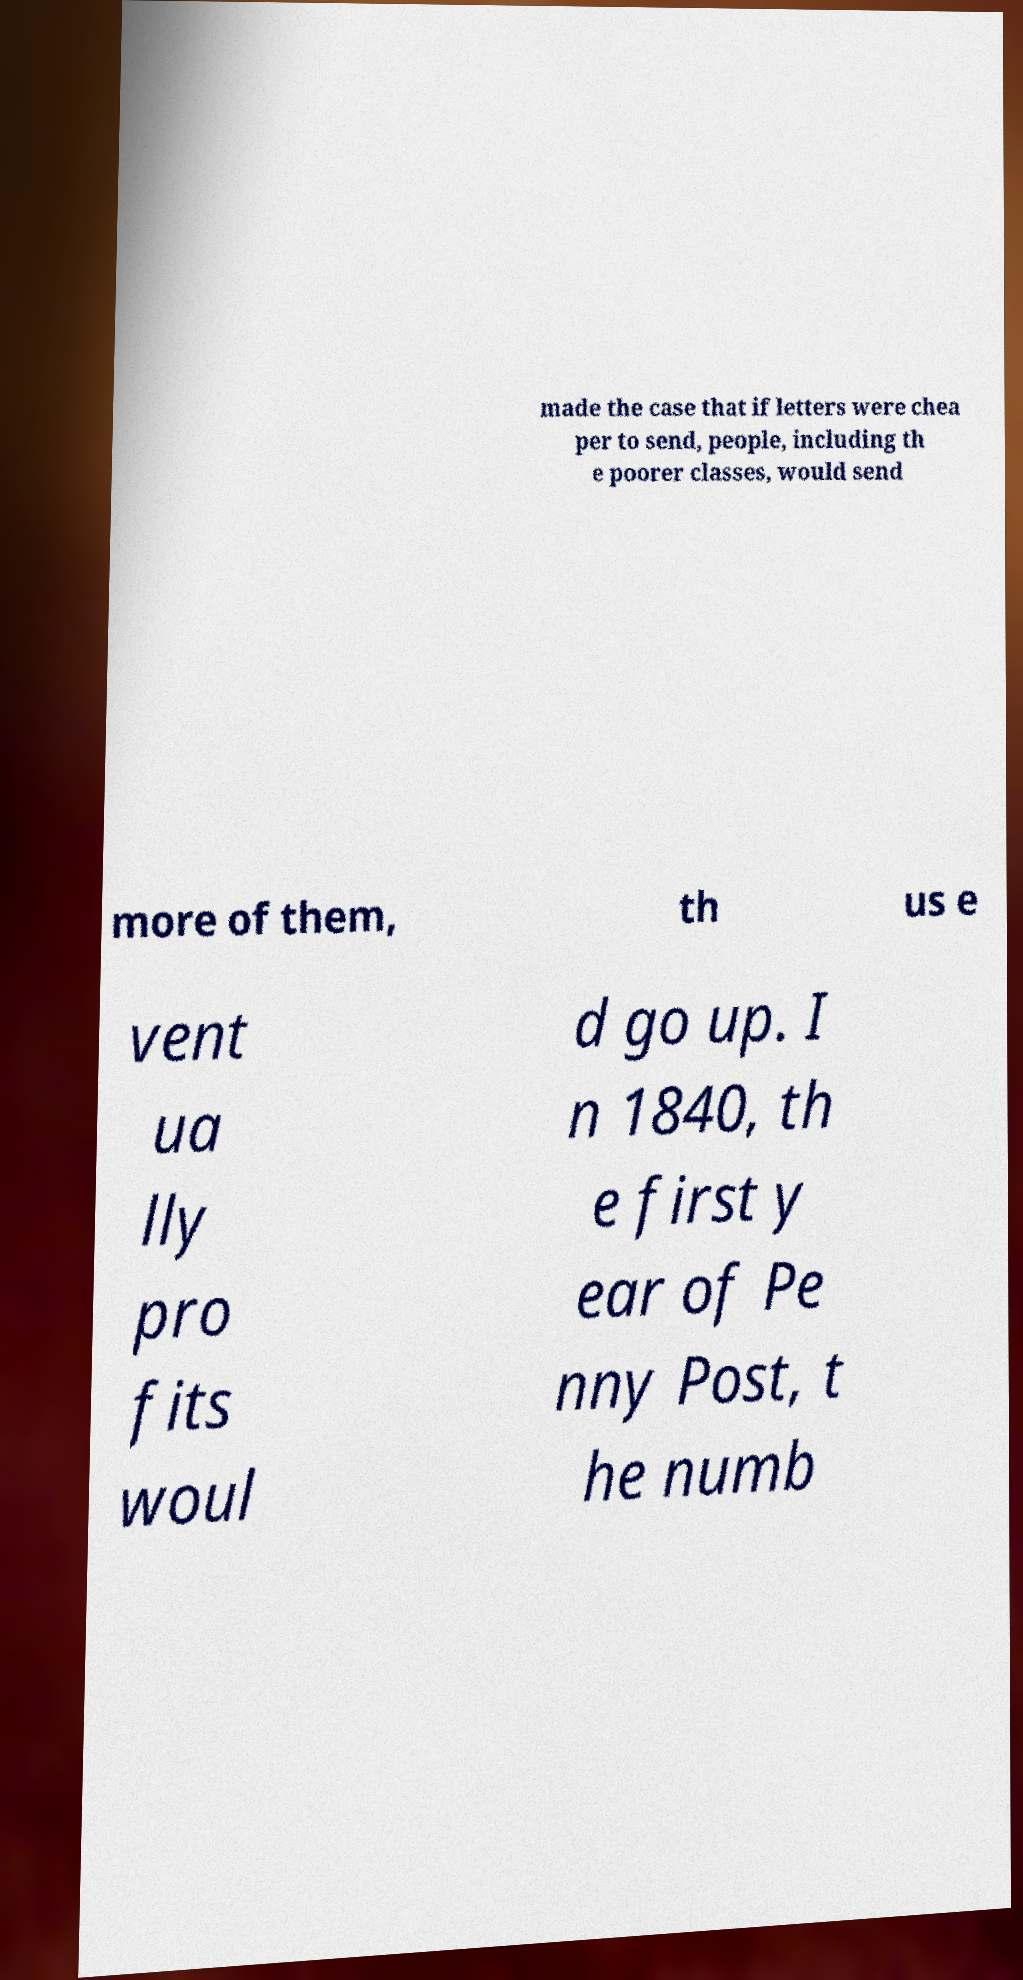Can you read and provide the text displayed in the image?This photo seems to have some interesting text. Can you extract and type it out for me? made the case that if letters were chea per to send, people, including th e poorer classes, would send more of them, th us e vent ua lly pro fits woul d go up. I n 1840, th e first y ear of Pe nny Post, t he numb 